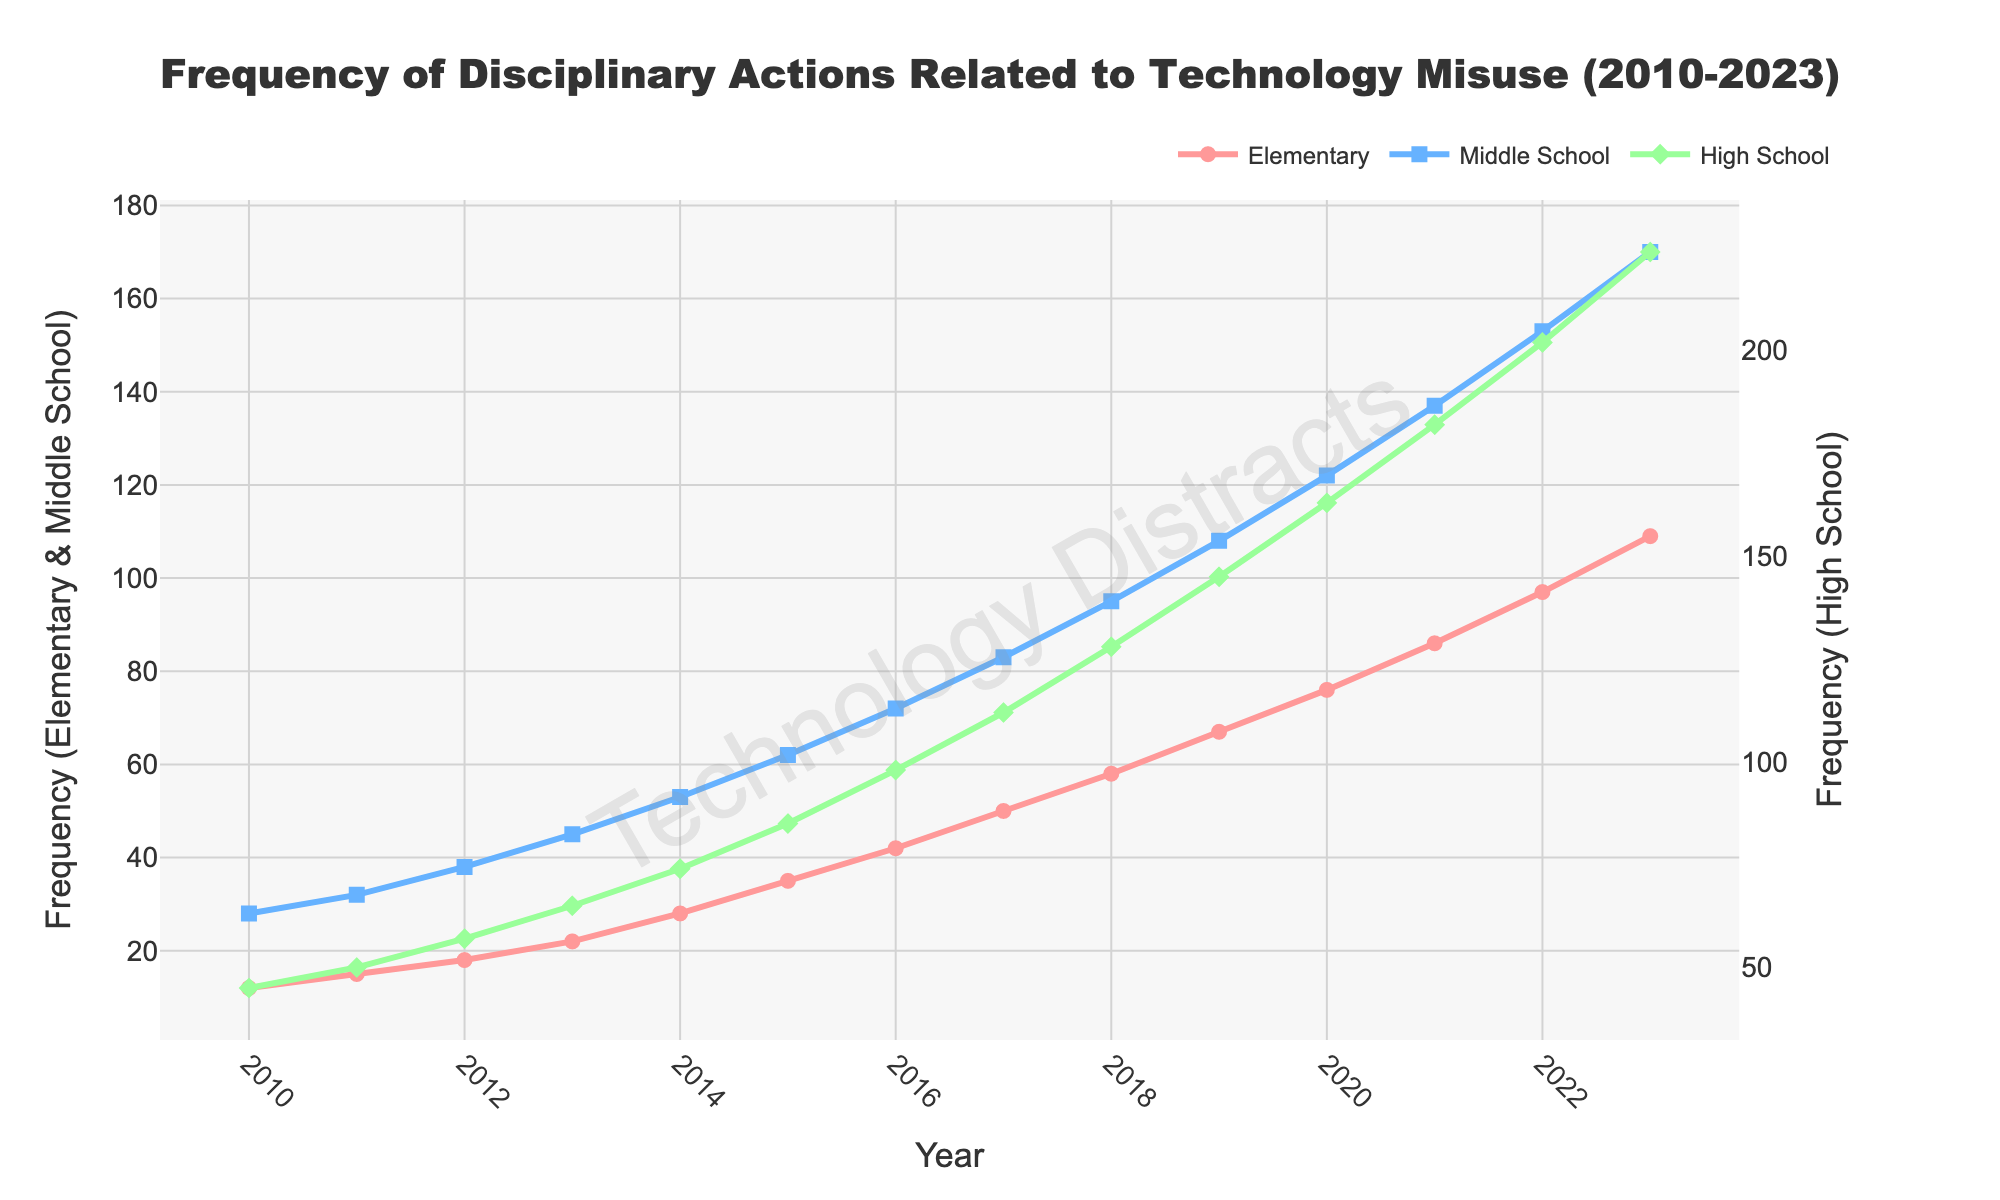Which grade level experienced the highest increase in disciplinary actions from 2010 to 2023? The largest increase can be calculated by subtracting the 2010 value from the 2023 value for each grade level and comparing the results: Elementary (109 - 12 = 97), Middle School (170 - 28 = 142), High School (224 - 45 = 179). High School shows the highest increase.
Answer: High School What is the average number of disciplinary actions for Middle School over the years? Add up the disciplinary actions for Middle School for each year and divide by the number of years: (28 + 32 + 38 + 45 + 53 + 62 + 72 + 83 + 95 + 108 + 122 + 137 + 153 + 170) / 14 = 101.57.
Answer: 101.57 In which year did Elementary and High School have the same increase in disciplinary actions compared to the previous year? The increase can be calculated by the difference between consecutive years. The same increase means increment for both Elementary and High School matches in a particular year. After calculations, it appears in 2016. Elementary: 42 - 35 = 7, High School: 98 - 91 = 7.
Answer: 2016 What was the total number of technology misuse incidents recorded across all grade levels in 2020? Sum the values for all grade levels for the year 2020: Elementary (76) + Middle School (122) + High School (163) = 361.
Answer: 361 Between which consecutive years did High School see the largest increase in disciplinary actions? Calculate the differences for each consecutive year pair and compare: (2017-2016) 112-98 = 14, (2023-2022) 224-202 = 22, 2020-2019 shows the largest increase.
Answer: 2020-2019 Which grade level had the lowest frequency of disciplinary actions in 2011? Look at the values for 2011 and find the lowest: Elementary (15), Middle School (32), High School (50).
Answer: Elementary By how much did the disciplinary actions for Middle School increase from 2018 to 2023? Subtract the value in 2018 from the value in 2023 for Middle School: 170 - 95 = 75.
Answer: 75 What is the approximate slope of the line representing Middle School disciplinary actions from 2010 to 2023? The slope can be found using (170 - 28) / (2023 - 2010): (142 / 13). The approximate slope is ~10.92.
Answer: ~10.92 During which year did Elementary School have approximately the same number of disciplinary actions as Middle School's count in 2014? Look for the corresponding values: Middle School in 2014 = 53, Elementary has 50 close to 53 in 2017.
Answer: 2017 